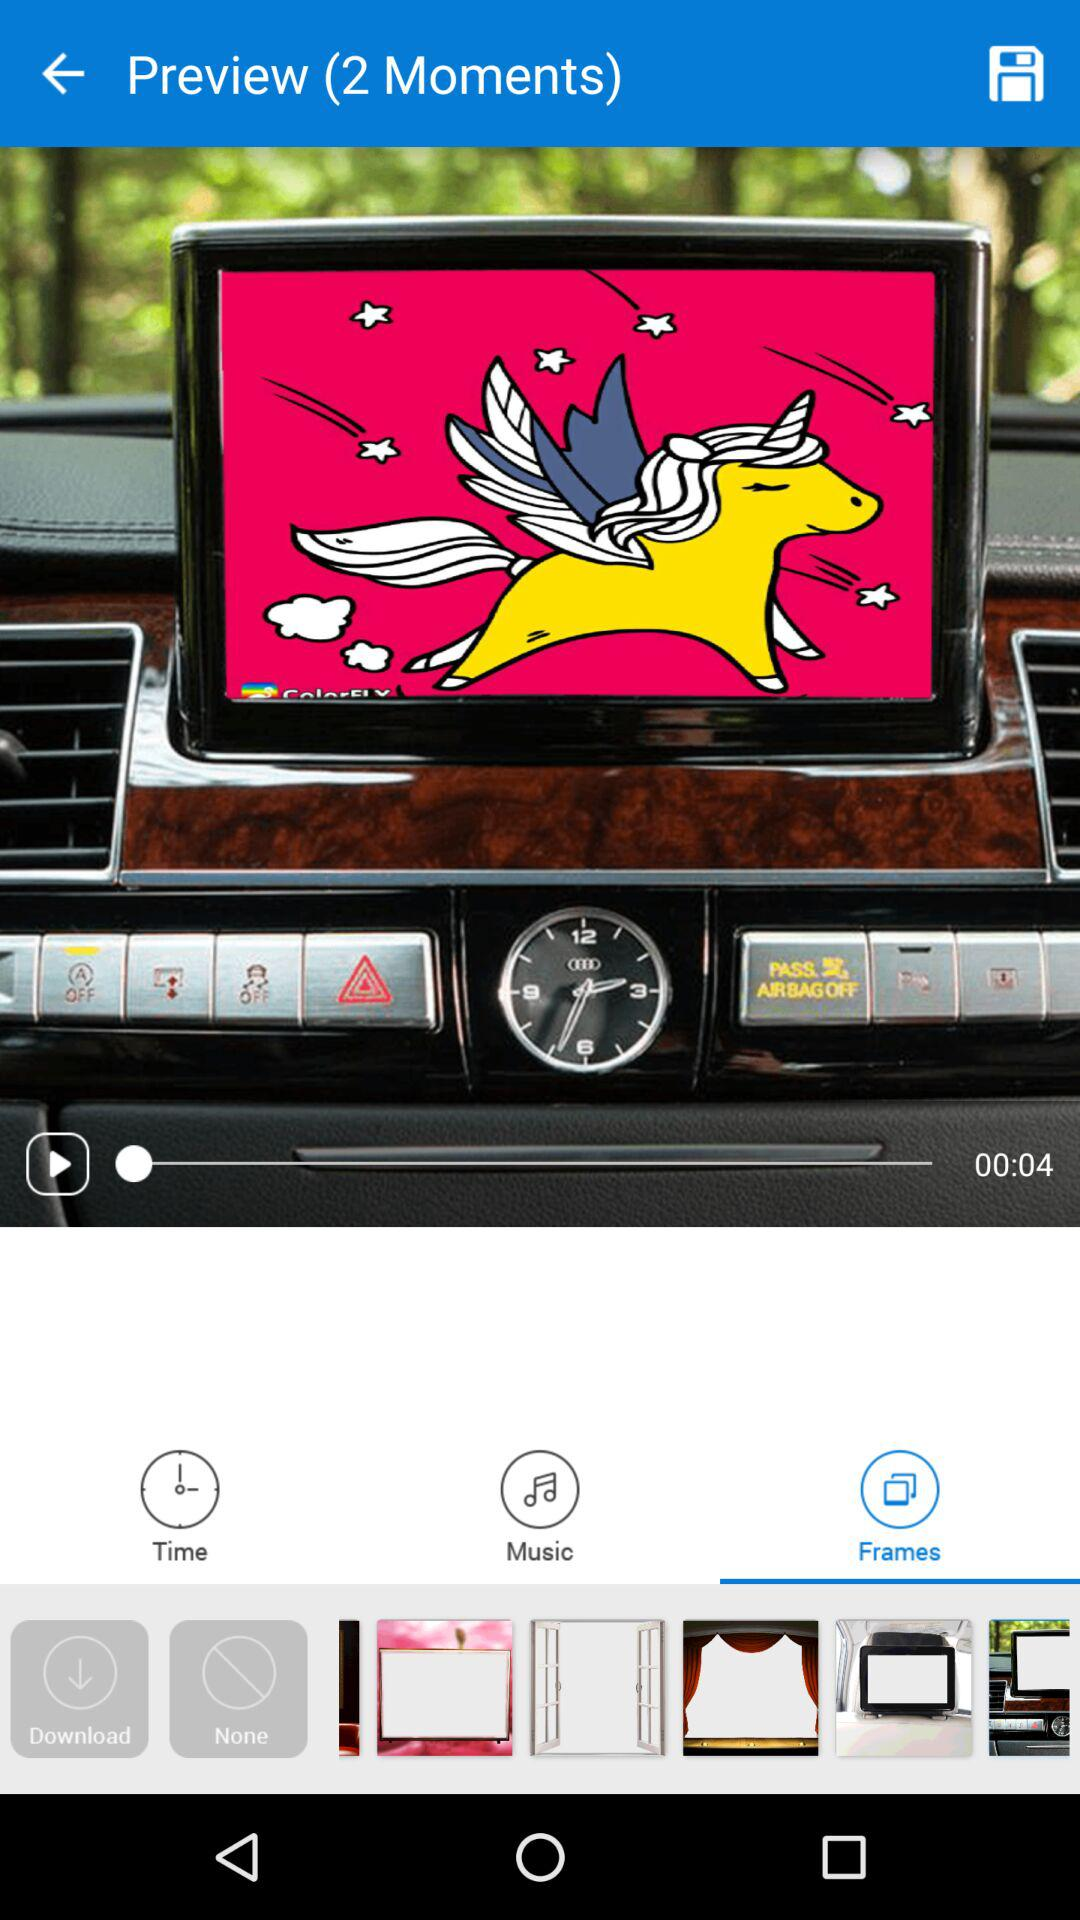What is the length of the video? The length of the video is 4 seconds. 